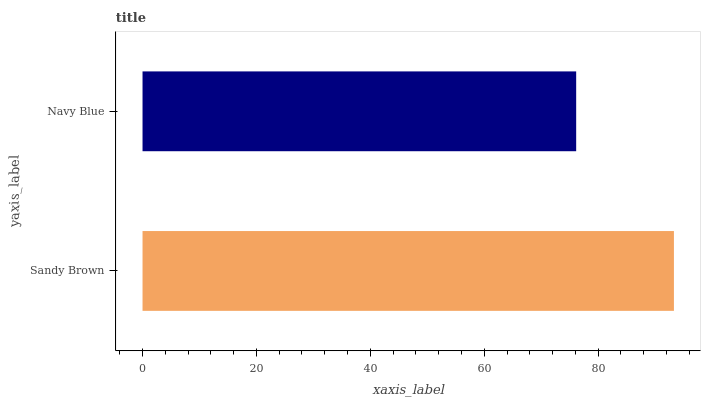Is Navy Blue the minimum?
Answer yes or no. Yes. Is Sandy Brown the maximum?
Answer yes or no. Yes. Is Navy Blue the maximum?
Answer yes or no. No. Is Sandy Brown greater than Navy Blue?
Answer yes or no. Yes. Is Navy Blue less than Sandy Brown?
Answer yes or no. Yes. Is Navy Blue greater than Sandy Brown?
Answer yes or no. No. Is Sandy Brown less than Navy Blue?
Answer yes or no. No. Is Sandy Brown the high median?
Answer yes or no. Yes. Is Navy Blue the low median?
Answer yes or no. Yes. Is Navy Blue the high median?
Answer yes or no. No. Is Sandy Brown the low median?
Answer yes or no. No. 